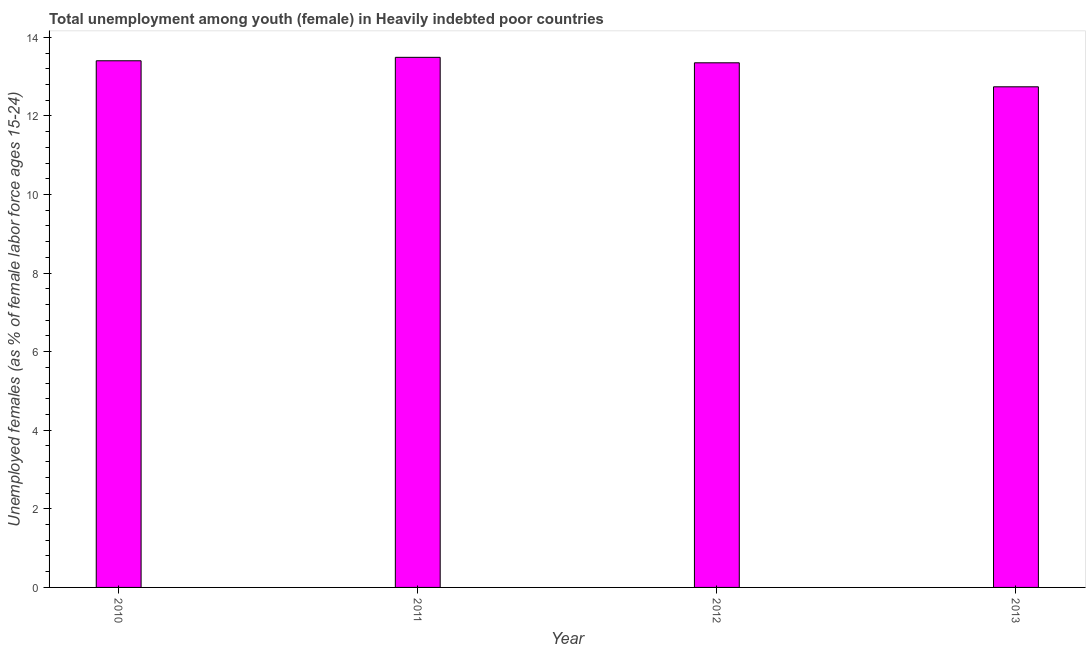What is the title of the graph?
Your answer should be compact. Total unemployment among youth (female) in Heavily indebted poor countries. What is the label or title of the X-axis?
Provide a succinct answer. Year. What is the label or title of the Y-axis?
Make the answer very short. Unemployed females (as % of female labor force ages 15-24). What is the unemployed female youth population in 2012?
Keep it short and to the point. 13.35. Across all years, what is the maximum unemployed female youth population?
Give a very brief answer. 13.49. Across all years, what is the minimum unemployed female youth population?
Give a very brief answer. 12.74. In which year was the unemployed female youth population minimum?
Give a very brief answer. 2013. What is the sum of the unemployed female youth population?
Your answer should be compact. 52.99. What is the difference between the unemployed female youth population in 2010 and 2011?
Keep it short and to the point. -0.09. What is the average unemployed female youth population per year?
Your answer should be very brief. 13.25. What is the median unemployed female youth population?
Give a very brief answer. 13.38. In how many years, is the unemployed female youth population greater than 12.4 %?
Provide a short and direct response. 4. Is the unemployed female youth population in 2011 less than that in 2013?
Your response must be concise. No. Is the difference between the unemployed female youth population in 2011 and 2012 greater than the difference between any two years?
Make the answer very short. No. What is the difference between the highest and the second highest unemployed female youth population?
Keep it short and to the point. 0.09. Is the sum of the unemployed female youth population in 2010 and 2012 greater than the maximum unemployed female youth population across all years?
Make the answer very short. Yes. What is the difference between the highest and the lowest unemployed female youth population?
Give a very brief answer. 0.75. How many years are there in the graph?
Offer a terse response. 4. What is the difference between two consecutive major ticks on the Y-axis?
Provide a short and direct response. 2. Are the values on the major ticks of Y-axis written in scientific E-notation?
Provide a succinct answer. No. What is the Unemployed females (as % of female labor force ages 15-24) in 2010?
Offer a very short reply. 13.4. What is the Unemployed females (as % of female labor force ages 15-24) in 2011?
Offer a terse response. 13.49. What is the Unemployed females (as % of female labor force ages 15-24) of 2012?
Your answer should be very brief. 13.35. What is the Unemployed females (as % of female labor force ages 15-24) of 2013?
Offer a terse response. 12.74. What is the difference between the Unemployed females (as % of female labor force ages 15-24) in 2010 and 2011?
Ensure brevity in your answer.  -0.09. What is the difference between the Unemployed females (as % of female labor force ages 15-24) in 2010 and 2012?
Ensure brevity in your answer.  0.05. What is the difference between the Unemployed females (as % of female labor force ages 15-24) in 2010 and 2013?
Keep it short and to the point. 0.66. What is the difference between the Unemployed females (as % of female labor force ages 15-24) in 2011 and 2012?
Your answer should be very brief. 0.14. What is the difference between the Unemployed females (as % of female labor force ages 15-24) in 2011 and 2013?
Make the answer very short. 0.75. What is the difference between the Unemployed females (as % of female labor force ages 15-24) in 2012 and 2013?
Give a very brief answer. 0.61. What is the ratio of the Unemployed females (as % of female labor force ages 15-24) in 2010 to that in 2013?
Your response must be concise. 1.05. What is the ratio of the Unemployed females (as % of female labor force ages 15-24) in 2011 to that in 2013?
Offer a very short reply. 1.06. What is the ratio of the Unemployed females (as % of female labor force ages 15-24) in 2012 to that in 2013?
Offer a terse response. 1.05. 